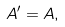<formula> <loc_0><loc_0><loc_500><loc_500>A ^ { \prime } = A ,</formula> 